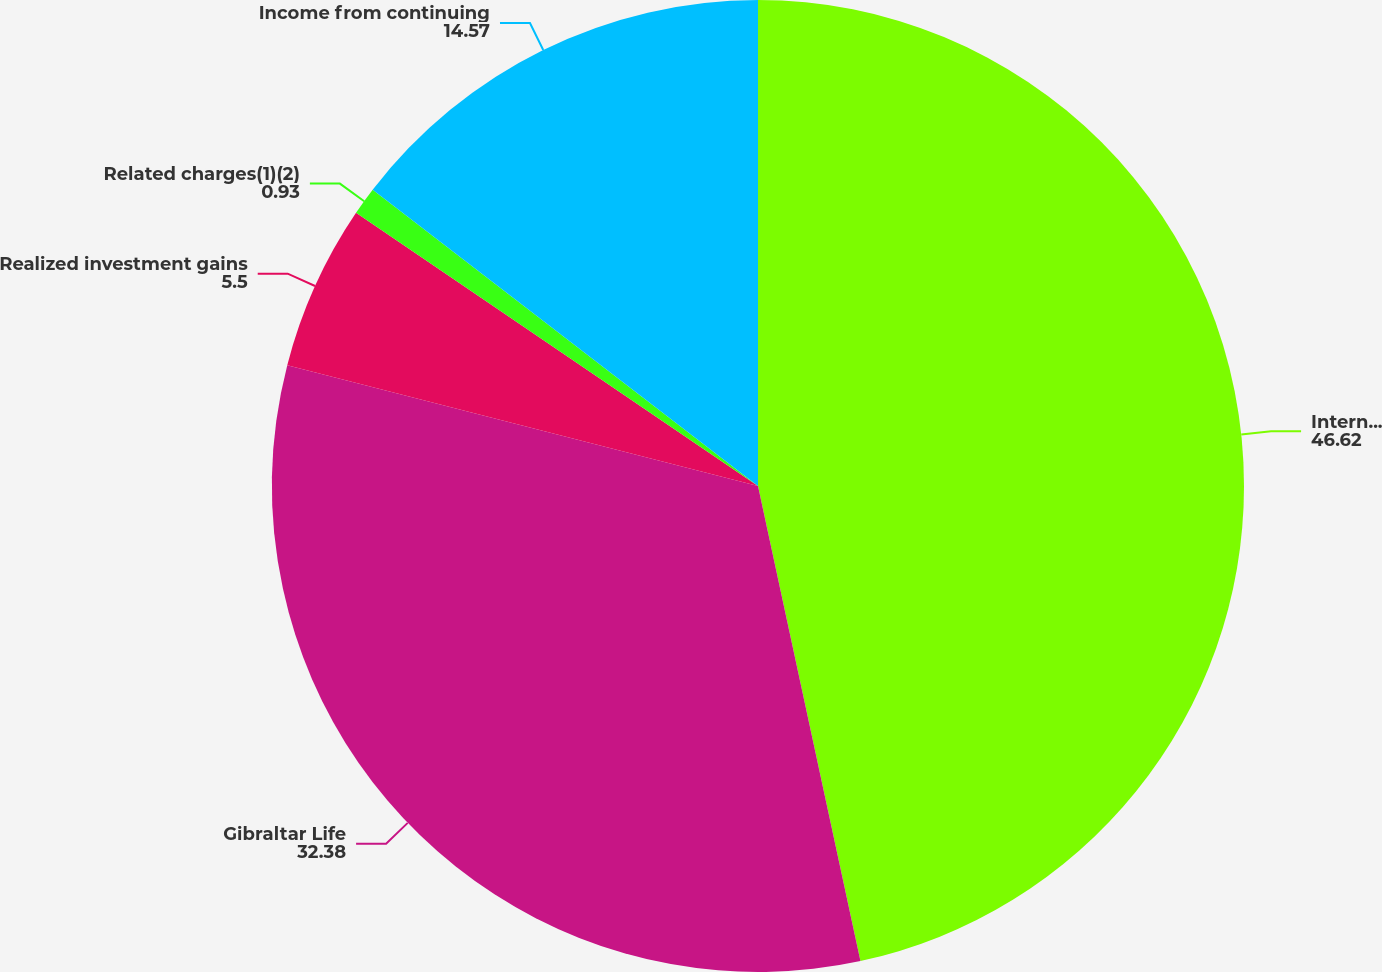Convert chart. <chart><loc_0><loc_0><loc_500><loc_500><pie_chart><fcel>International Insurance<fcel>Gibraltar Life<fcel>Realized investment gains<fcel>Related charges(1)(2)<fcel>Income from continuing<nl><fcel>46.62%<fcel>32.38%<fcel>5.5%<fcel>0.93%<fcel>14.57%<nl></chart> 